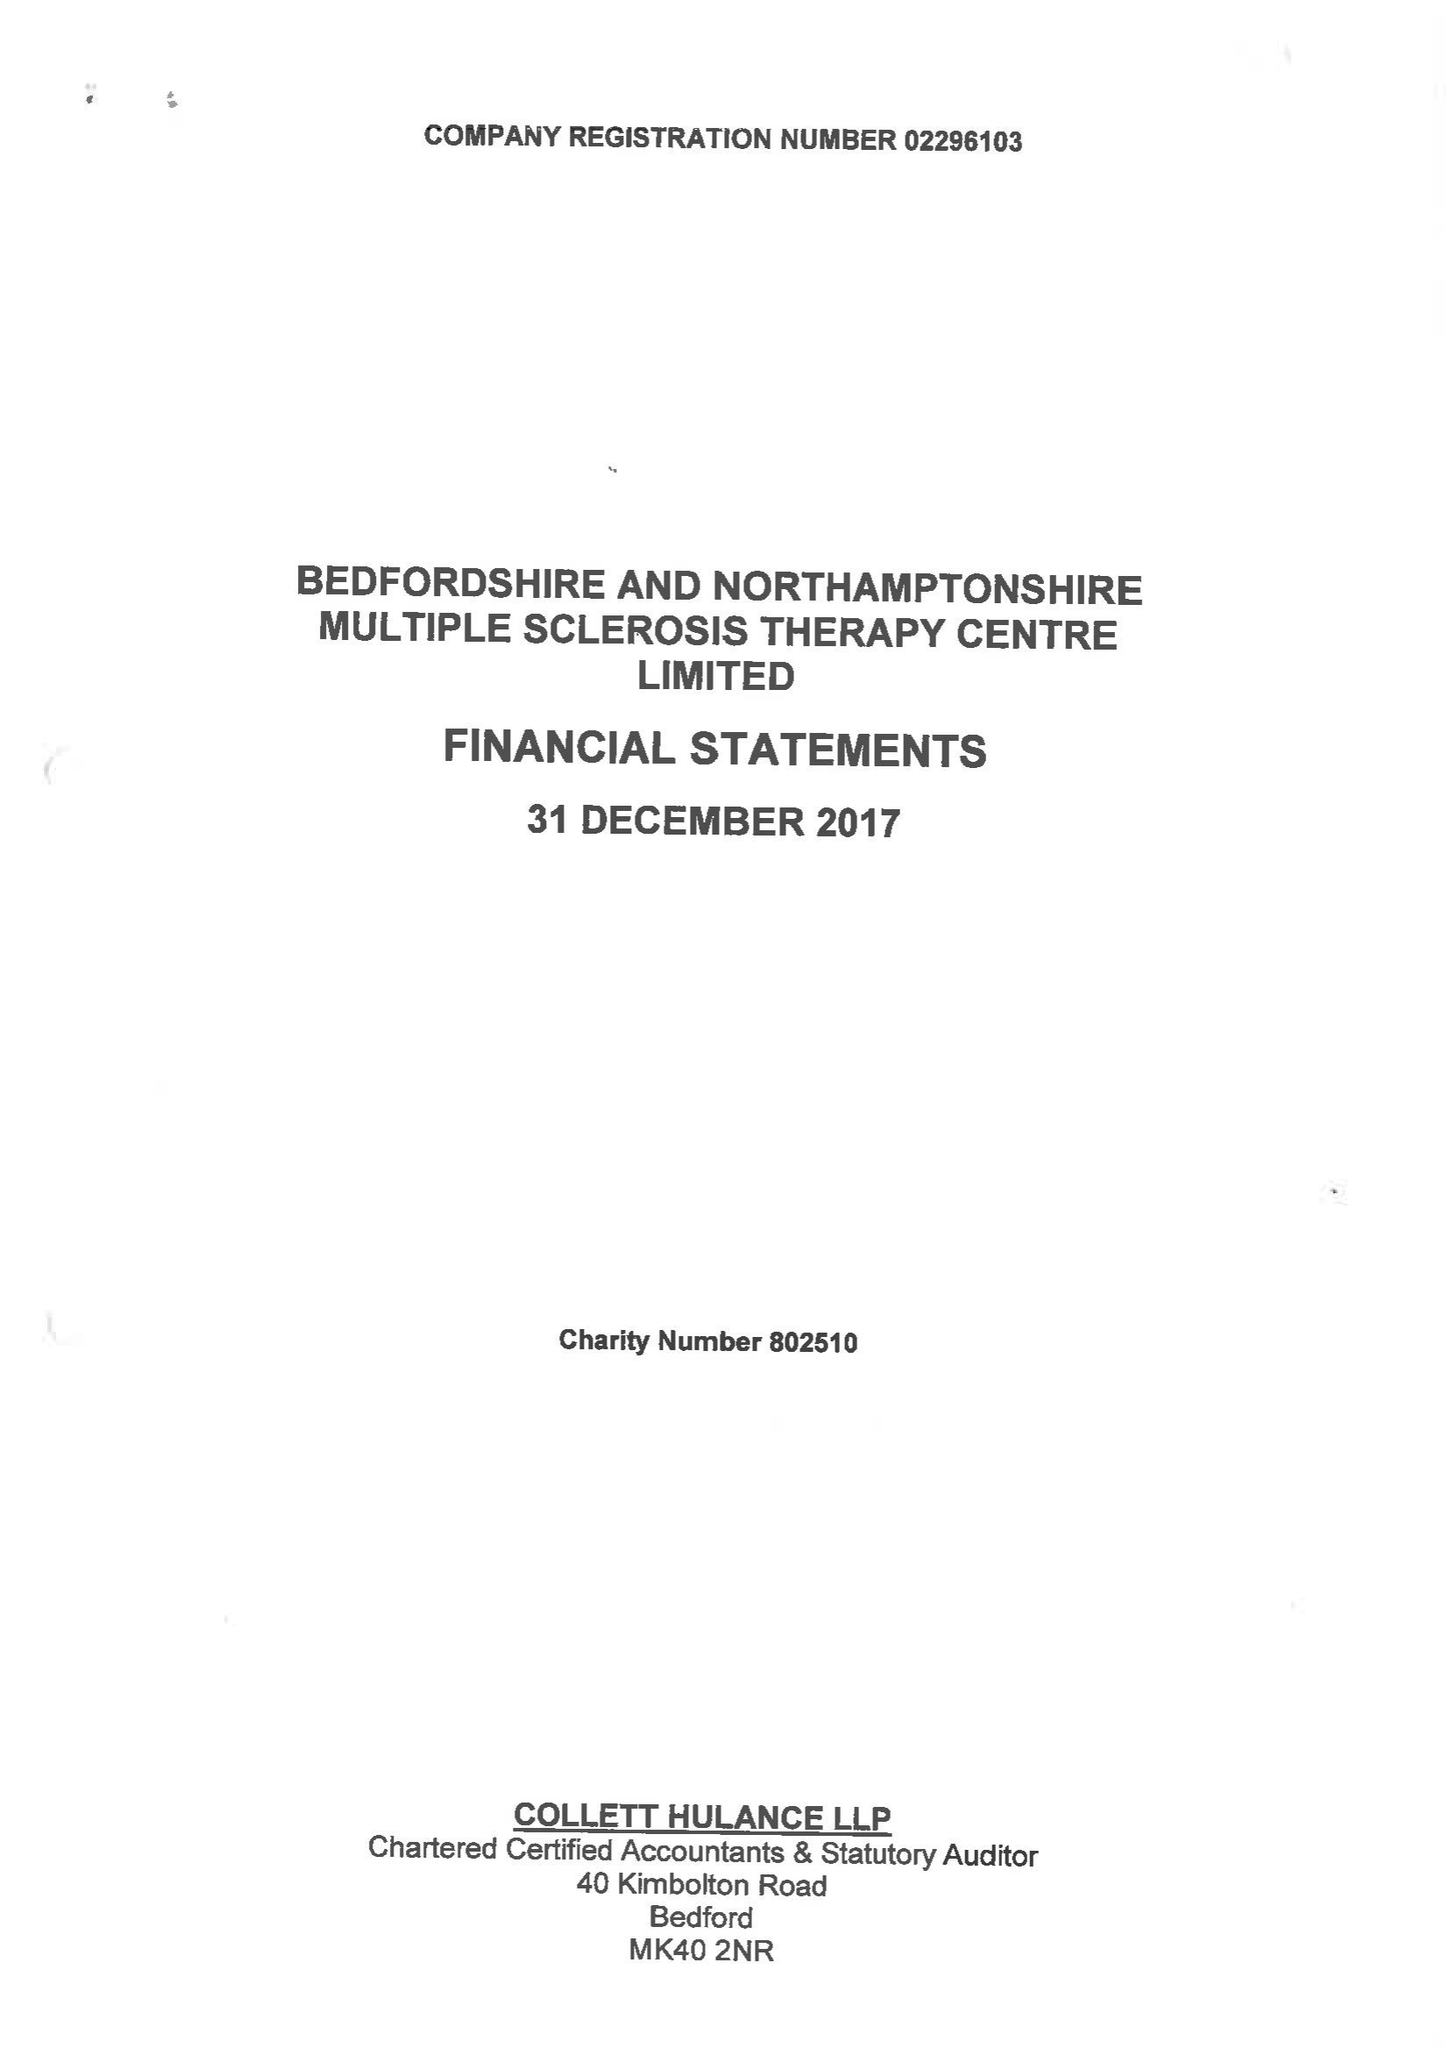What is the value for the report_date?
Answer the question using a single word or phrase. 2017-12-31 